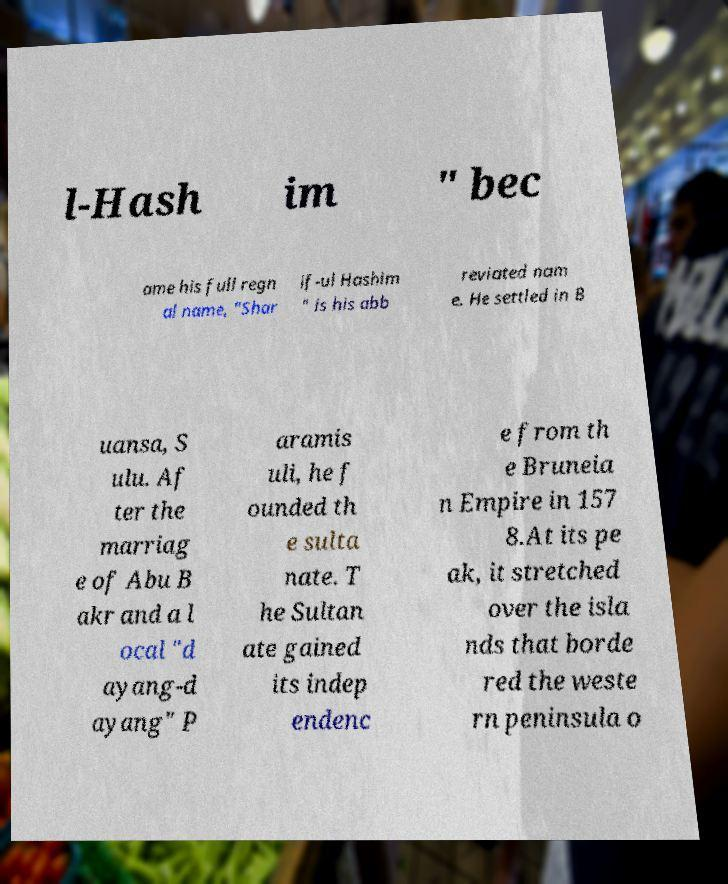Could you assist in decoding the text presented in this image and type it out clearly? l-Hash im " bec ame his full regn al name, "Shar if-ul Hashim " is his abb reviated nam e. He settled in B uansa, S ulu. Af ter the marriag e of Abu B akr and a l ocal "d ayang-d ayang" P aramis uli, he f ounded th e sulta nate. T he Sultan ate gained its indep endenc e from th e Bruneia n Empire in 157 8.At its pe ak, it stretched over the isla nds that borde red the weste rn peninsula o 